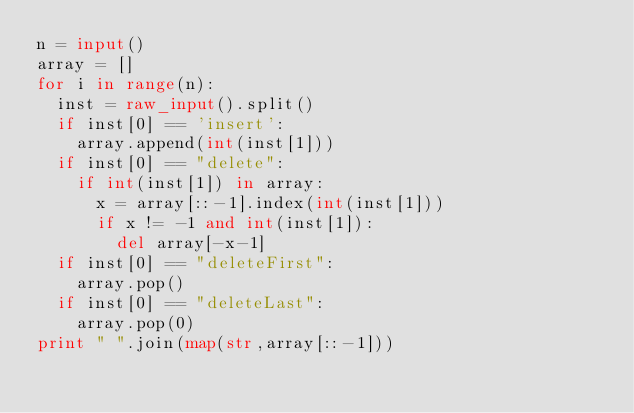<code> <loc_0><loc_0><loc_500><loc_500><_Python_>n = input()
array = []
for i in range(n):
	inst = raw_input().split()
	if inst[0] == 'insert':
		array.append(int(inst[1]))
	if inst[0] == "delete":
		if int(inst[1]) in array:
			x = array[::-1].index(int(inst[1]))
			if x != -1 and int(inst[1]):
				del array[-x-1]
	if inst[0] == "deleteFirst":
		array.pop()
	if inst[0] == "deleteLast":
		array.pop(0)
print " ".join(map(str,array[::-1]))</code> 